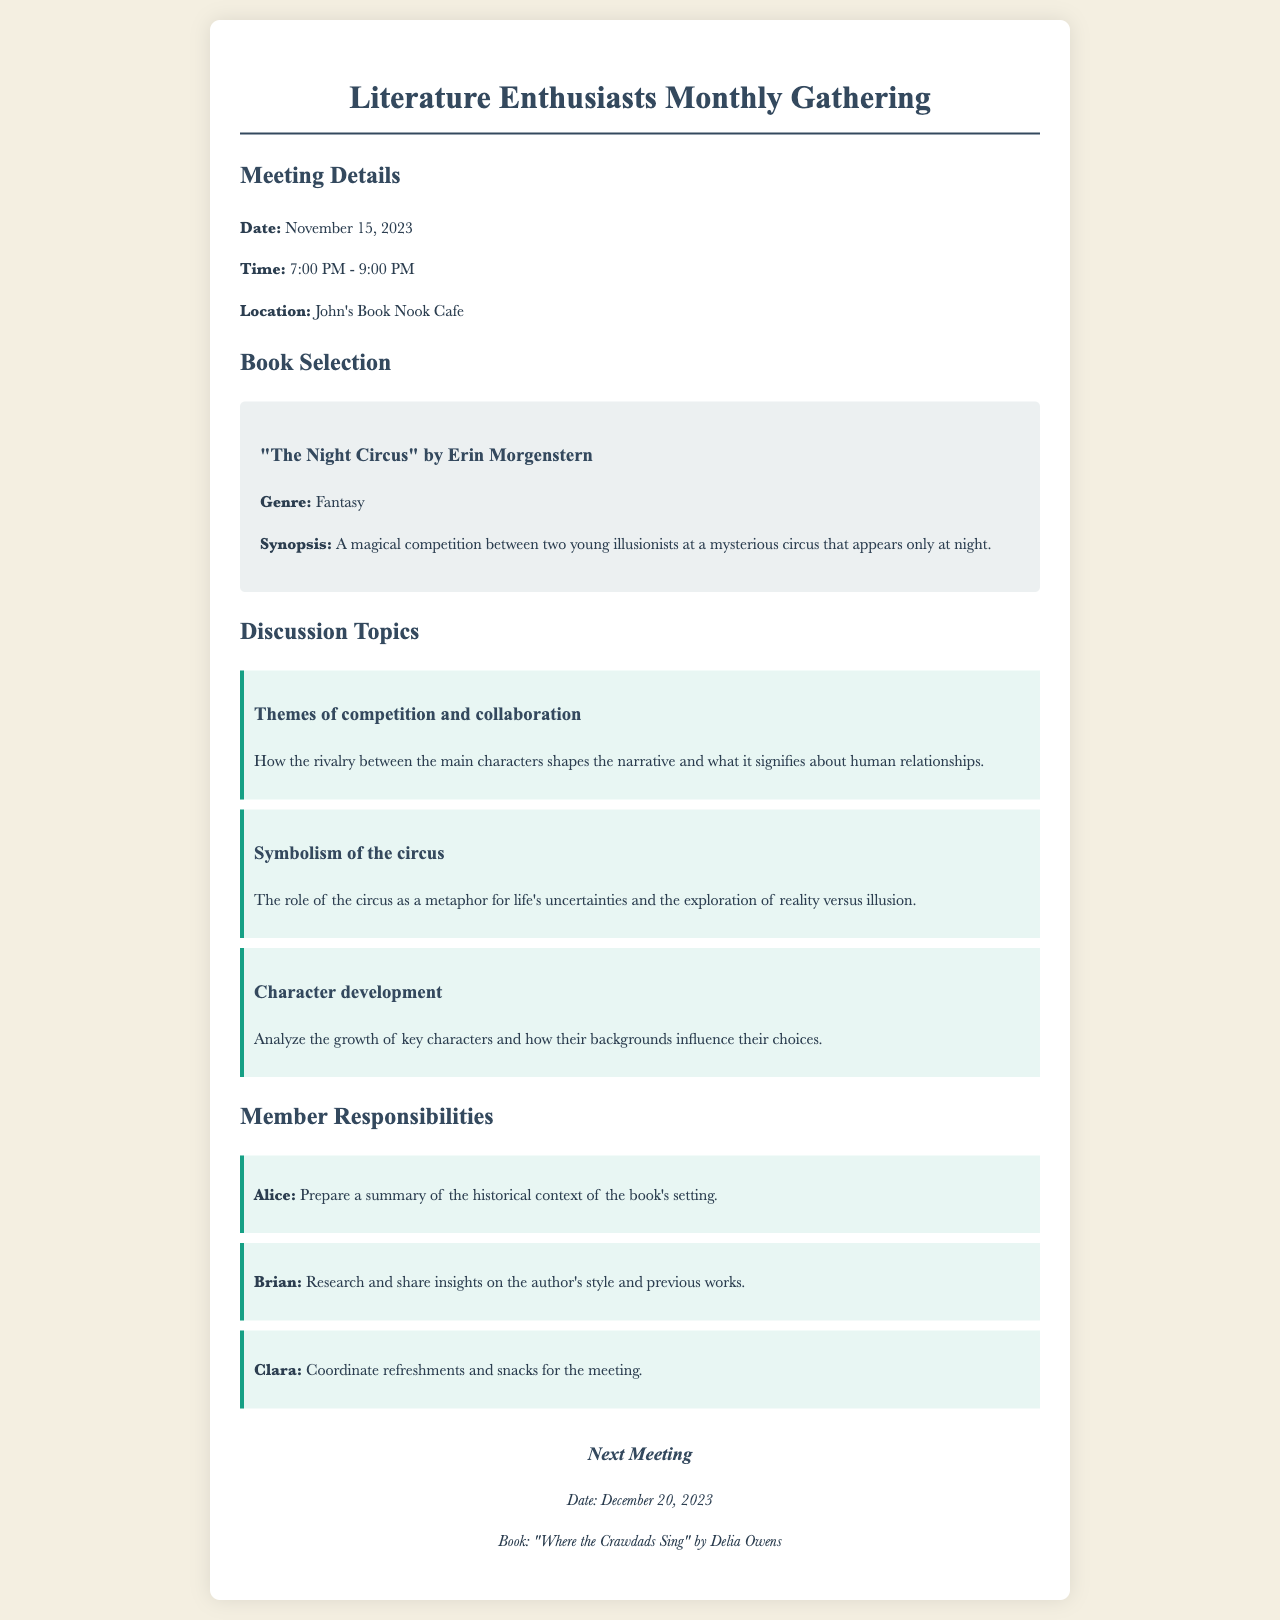What is the date of the meeting? The date of the meeting is explicitly mentioned in the document under "Meeting Details."
Answer: November 15, 2023 What is the title of the book discussed this month? The title of the book is clearly stated in the "Book Selection" section.
Answer: "The Night Circus" by Erin Morgenstern What time does the meeting start? The starting time of the meeting is included in the "Meeting Details" section.
Answer: 7:00 PM Who is responsible for coordinating refreshments? The responsibility for coordinating refreshments is listed in the "Member Responsibilities" section.
Answer: Clara What are the themes discussed in the meeting? The themes can be found in the "Discussion Topics" section, which highlights specific areas of discussion.
Answer: Themes of competition and collaboration How many discussion topics are outlined in the document? The number of topics can be counted from the "Discussion Topics" section in the document.
Answer: Three What is the name of the cafe where the meeting will take place? The location of the meeting is detailed in the "Meeting Details" section.
Answer: John's Book Nook Cafe When is the next meeting scheduled? The date of the next meeting is mentioned in the "Next Meeting" section.
Answer: December 20, 2023 What is the genre of the selected book? The genre of the book is indicated in the "Book Selection" section.
Answer: Fantasy 